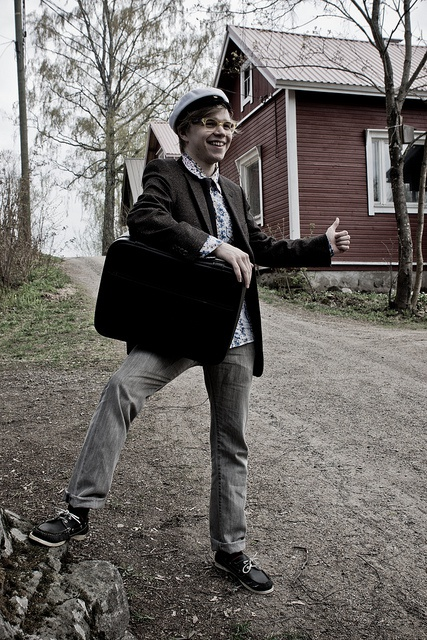Describe the objects in this image and their specific colors. I can see people in lightgray, black, gray, and darkgray tones, suitcase in lightgray, black, darkgray, and gray tones, and tie in lightgray, black, and gray tones in this image. 